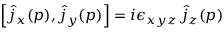<formula> <loc_0><loc_0><loc_500><loc_500>\left [ \hat { j } _ { x } ( p ) , \hat { j } _ { y } ( p ) \right ] = i \epsilon _ { x y z } \, \hat { j } _ { z } ( p )</formula> 